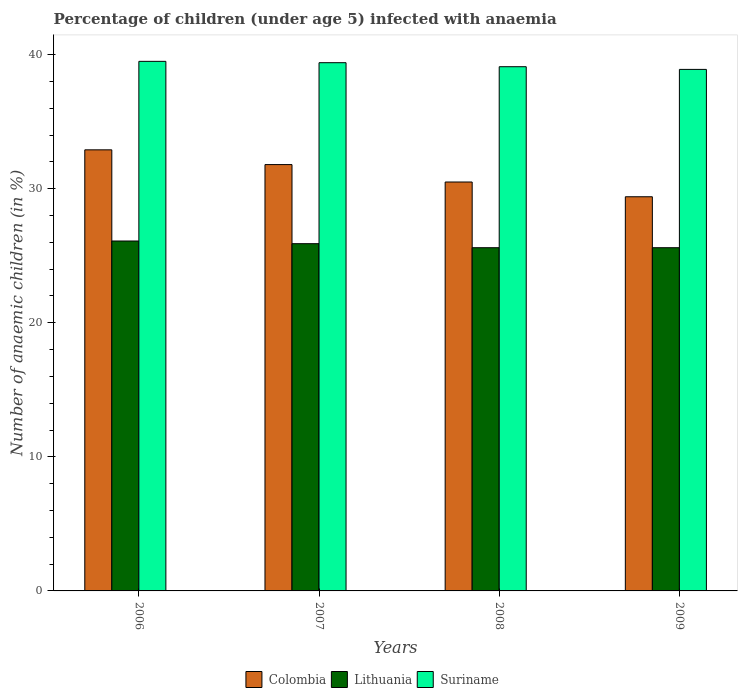How many different coloured bars are there?
Your response must be concise. 3. How many groups of bars are there?
Ensure brevity in your answer.  4. Are the number of bars per tick equal to the number of legend labels?
Your response must be concise. Yes. Are the number of bars on each tick of the X-axis equal?
Offer a terse response. Yes. How many bars are there on the 1st tick from the right?
Your answer should be compact. 3. What is the label of the 2nd group of bars from the left?
Provide a short and direct response. 2007. What is the percentage of children infected with anaemia in in Colombia in 2008?
Keep it short and to the point. 30.5. Across all years, what is the maximum percentage of children infected with anaemia in in Colombia?
Your answer should be very brief. 32.9. Across all years, what is the minimum percentage of children infected with anaemia in in Lithuania?
Keep it short and to the point. 25.6. In which year was the percentage of children infected with anaemia in in Lithuania minimum?
Provide a short and direct response. 2008. What is the total percentage of children infected with anaemia in in Colombia in the graph?
Give a very brief answer. 124.6. What is the difference between the percentage of children infected with anaemia in in Lithuania in 2009 and the percentage of children infected with anaemia in in Colombia in 2006?
Your answer should be very brief. -7.3. What is the average percentage of children infected with anaemia in in Colombia per year?
Provide a succinct answer. 31.15. In the year 2007, what is the difference between the percentage of children infected with anaemia in in Suriname and percentage of children infected with anaemia in in Colombia?
Give a very brief answer. 7.6. What is the ratio of the percentage of children infected with anaemia in in Suriname in 2006 to that in 2009?
Offer a very short reply. 1.02. What is the difference between the highest and the second highest percentage of children infected with anaemia in in Colombia?
Make the answer very short. 1.1. What is the difference between the highest and the lowest percentage of children infected with anaemia in in Suriname?
Provide a short and direct response. 0.6. In how many years, is the percentage of children infected with anaemia in in Colombia greater than the average percentage of children infected with anaemia in in Colombia taken over all years?
Offer a terse response. 2. What does the 2nd bar from the left in 2006 represents?
Offer a very short reply. Lithuania. What does the 1st bar from the right in 2008 represents?
Give a very brief answer. Suriname. Is it the case that in every year, the sum of the percentage of children infected with anaemia in in Suriname and percentage of children infected with anaemia in in Lithuania is greater than the percentage of children infected with anaemia in in Colombia?
Make the answer very short. Yes. How many bars are there?
Keep it short and to the point. 12. What is the title of the graph?
Your answer should be very brief. Percentage of children (under age 5) infected with anaemia. What is the label or title of the Y-axis?
Make the answer very short. Number of anaemic children (in %). What is the Number of anaemic children (in %) of Colombia in 2006?
Offer a terse response. 32.9. What is the Number of anaemic children (in %) of Lithuania in 2006?
Give a very brief answer. 26.1. What is the Number of anaemic children (in %) in Suriname in 2006?
Provide a succinct answer. 39.5. What is the Number of anaemic children (in %) in Colombia in 2007?
Offer a terse response. 31.8. What is the Number of anaemic children (in %) in Lithuania in 2007?
Make the answer very short. 25.9. What is the Number of anaemic children (in %) of Suriname in 2007?
Offer a terse response. 39.4. What is the Number of anaemic children (in %) of Colombia in 2008?
Give a very brief answer. 30.5. What is the Number of anaemic children (in %) in Lithuania in 2008?
Make the answer very short. 25.6. What is the Number of anaemic children (in %) in Suriname in 2008?
Offer a very short reply. 39.1. What is the Number of anaemic children (in %) of Colombia in 2009?
Your response must be concise. 29.4. What is the Number of anaemic children (in %) in Lithuania in 2009?
Offer a very short reply. 25.6. What is the Number of anaemic children (in %) in Suriname in 2009?
Your answer should be compact. 38.9. Across all years, what is the maximum Number of anaemic children (in %) of Colombia?
Your answer should be very brief. 32.9. Across all years, what is the maximum Number of anaemic children (in %) in Lithuania?
Your answer should be very brief. 26.1. Across all years, what is the maximum Number of anaemic children (in %) of Suriname?
Provide a succinct answer. 39.5. Across all years, what is the minimum Number of anaemic children (in %) in Colombia?
Give a very brief answer. 29.4. Across all years, what is the minimum Number of anaemic children (in %) in Lithuania?
Your answer should be very brief. 25.6. Across all years, what is the minimum Number of anaemic children (in %) of Suriname?
Ensure brevity in your answer.  38.9. What is the total Number of anaemic children (in %) of Colombia in the graph?
Provide a succinct answer. 124.6. What is the total Number of anaemic children (in %) of Lithuania in the graph?
Offer a terse response. 103.2. What is the total Number of anaemic children (in %) in Suriname in the graph?
Your answer should be compact. 156.9. What is the difference between the Number of anaemic children (in %) in Colombia in 2006 and that in 2007?
Give a very brief answer. 1.1. What is the difference between the Number of anaemic children (in %) of Lithuania in 2006 and that in 2007?
Your answer should be compact. 0.2. What is the difference between the Number of anaemic children (in %) of Suriname in 2006 and that in 2007?
Your answer should be compact. 0.1. What is the difference between the Number of anaemic children (in %) of Colombia in 2006 and that in 2008?
Offer a terse response. 2.4. What is the difference between the Number of anaemic children (in %) in Lithuania in 2006 and that in 2008?
Your response must be concise. 0.5. What is the difference between the Number of anaemic children (in %) of Suriname in 2006 and that in 2008?
Give a very brief answer. 0.4. What is the difference between the Number of anaemic children (in %) in Colombia in 2006 and that in 2009?
Provide a succinct answer. 3.5. What is the difference between the Number of anaemic children (in %) in Suriname in 2006 and that in 2009?
Keep it short and to the point. 0.6. What is the difference between the Number of anaemic children (in %) in Colombia in 2007 and that in 2008?
Keep it short and to the point. 1.3. What is the difference between the Number of anaemic children (in %) of Colombia in 2007 and that in 2009?
Offer a terse response. 2.4. What is the difference between the Number of anaemic children (in %) in Colombia in 2008 and that in 2009?
Your answer should be compact. 1.1. What is the difference between the Number of anaemic children (in %) of Suriname in 2008 and that in 2009?
Your response must be concise. 0.2. What is the difference between the Number of anaemic children (in %) of Colombia in 2006 and the Number of anaemic children (in %) of Lithuania in 2008?
Your answer should be compact. 7.3. What is the difference between the Number of anaemic children (in %) in Lithuania in 2006 and the Number of anaemic children (in %) in Suriname in 2008?
Your answer should be very brief. -13. What is the difference between the Number of anaemic children (in %) in Colombia in 2006 and the Number of anaemic children (in %) in Lithuania in 2009?
Provide a short and direct response. 7.3. What is the difference between the Number of anaemic children (in %) in Colombia in 2007 and the Number of anaemic children (in %) in Lithuania in 2009?
Give a very brief answer. 6.2. What is the difference between the Number of anaemic children (in %) in Lithuania in 2007 and the Number of anaemic children (in %) in Suriname in 2009?
Make the answer very short. -13. What is the difference between the Number of anaemic children (in %) of Colombia in 2008 and the Number of anaemic children (in %) of Suriname in 2009?
Keep it short and to the point. -8.4. What is the difference between the Number of anaemic children (in %) of Lithuania in 2008 and the Number of anaemic children (in %) of Suriname in 2009?
Ensure brevity in your answer.  -13.3. What is the average Number of anaemic children (in %) in Colombia per year?
Provide a short and direct response. 31.15. What is the average Number of anaemic children (in %) in Lithuania per year?
Make the answer very short. 25.8. What is the average Number of anaemic children (in %) in Suriname per year?
Give a very brief answer. 39.23. In the year 2006, what is the difference between the Number of anaemic children (in %) of Colombia and Number of anaemic children (in %) of Lithuania?
Provide a succinct answer. 6.8. In the year 2006, what is the difference between the Number of anaemic children (in %) of Colombia and Number of anaemic children (in %) of Suriname?
Make the answer very short. -6.6. In the year 2007, what is the difference between the Number of anaemic children (in %) of Colombia and Number of anaemic children (in %) of Lithuania?
Provide a short and direct response. 5.9. In the year 2008, what is the difference between the Number of anaemic children (in %) in Colombia and Number of anaemic children (in %) in Lithuania?
Provide a succinct answer. 4.9. In the year 2009, what is the difference between the Number of anaemic children (in %) of Lithuania and Number of anaemic children (in %) of Suriname?
Give a very brief answer. -13.3. What is the ratio of the Number of anaemic children (in %) in Colombia in 2006 to that in 2007?
Ensure brevity in your answer.  1.03. What is the ratio of the Number of anaemic children (in %) in Lithuania in 2006 to that in 2007?
Offer a terse response. 1.01. What is the ratio of the Number of anaemic children (in %) of Colombia in 2006 to that in 2008?
Give a very brief answer. 1.08. What is the ratio of the Number of anaemic children (in %) in Lithuania in 2006 to that in 2008?
Keep it short and to the point. 1.02. What is the ratio of the Number of anaemic children (in %) in Suriname in 2006 to that in 2008?
Keep it short and to the point. 1.01. What is the ratio of the Number of anaemic children (in %) in Colombia in 2006 to that in 2009?
Your answer should be compact. 1.12. What is the ratio of the Number of anaemic children (in %) of Lithuania in 2006 to that in 2009?
Make the answer very short. 1.02. What is the ratio of the Number of anaemic children (in %) in Suriname in 2006 to that in 2009?
Offer a very short reply. 1.02. What is the ratio of the Number of anaemic children (in %) in Colombia in 2007 to that in 2008?
Your answer should be compact. 1.04. What is the ratio of the Number of anaemic children (in %) in Lithuania in 2007 to that in 2008?
Your response must be concise. 1.01. What is the ratio of the Number of anaemic children (in %) of Suriname in 2007 to that in 2008?
Ensure brevity in your answer.  1.01. What is the ratio of the Number of anaemic children (in %) in Colombia in 2007 to that in 2009?
Keep it short and to the point. 1.08. What is the ratio of the Number of anaemic children (in %) in Lithuania in 2007 to that in 2009?
Offer a very short reply. 1.01. What is the ratio of the Number of anaemic children (in %) in Suriname in 2007 to that in 2009?
Your answer should be very brief. 1.01. What is the ratio of the Number of anaemic children (in %) in Colombia in 2008 to that in 2009?
Your response must be concise. 1.04. What is the difference between the highest and the lowest Number of anaemic children (in %) of Suriname?
Offer a very short reply. 0.6. 